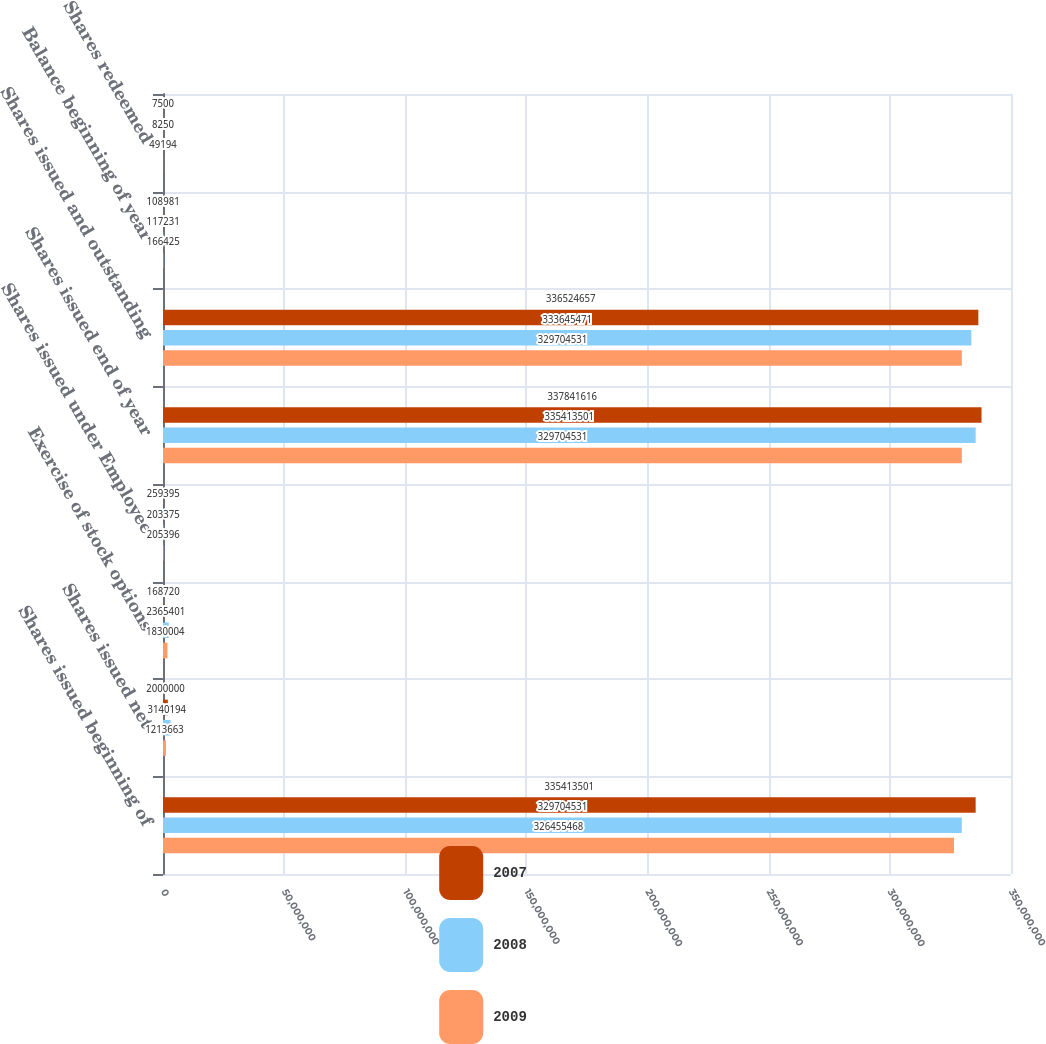<chart> <loc_0><loc_0><loc_500><loc_500><stacked_bar_chart><ecel><fcel>Shares issued beginning of<fcel>Shares issued net<fcel>Exercise of stock options<fcel>Shares issued under Employee<fcel>Shares issued end of year<fcel>Shares issued and outstanding<fcel>Balance beginning of year<fcel>Shares redeemed<nl><fcel>2007<fcel>3.35414e+08<fcel>2e+06<fcel>168720<fcel>259395<fcel>3.37842e+08<fcel>3.36525e+08<fcel>108981<fcel>7500<nl><fcel>2008<fcel>3.29705e+08<fcel>3.14019e+06<fcel>2.3654e+06<fcel>203375<fcel>3.35414e+08<fcel>3.33645e+08<fcel>117231<fcel>8250<nl><fcel>2009<fcel>3.26455e+08<fcel>1.21366e+06<fcel>1.83e+06<fcel>205396<fcel>3.29705e+08<fcel>3.29705e+08<fcel>166425<fcel>49194<nl></chart> 